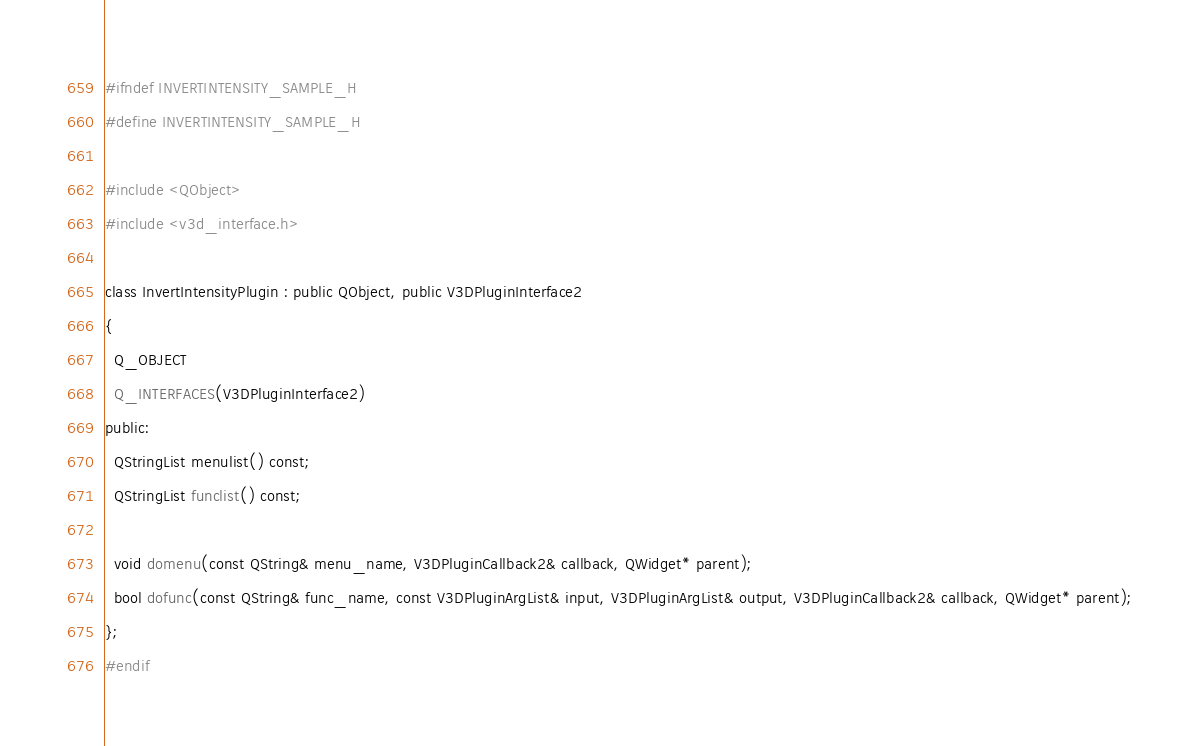<code> <loc_0><loc_0><loc_500><loc_500><_C_>#ifndef INVERTINTENSITY_SAMPLE_H
#define INVERTINTENSITY_SAMPLE_H

#include <QObject>
#include <v3d_interface.h>

class InvertIntensityPlugin : public QObject, public V3DPluginInterface2
{
  Q_OBJECT
  Q_INTERFACES(V3DPluginInterface2)
public:
  QStringList menulist() const;
  QStringList funclist() const;

  void domenu(const QString& menu_name, V3DPluginCallback2& callback, QWidget* parent);
  bool dofunc(const QString& func_name, const V3DPluginArgList& input, V3DPluginArgList& output, V3DPluginCallback2& callback, QWidget* parent);
};
#endif
</code> 